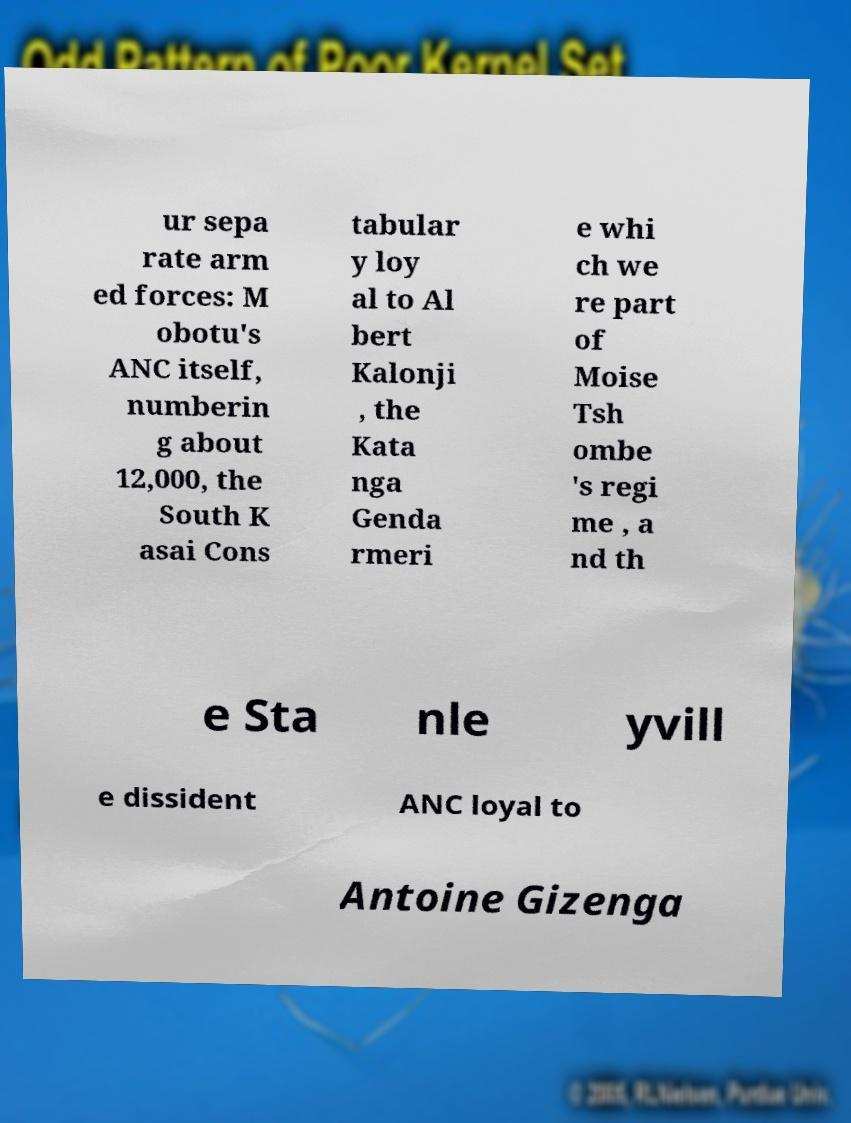Can you accurately transcribe the text from the provided image for me? ur sepa rate arm ed forces: M obotu's ANC itself, numberin g about 12,000, the South K asai Cons tabular y loy al to Al bert Kalonji , the Kata nga Genda rmeri e whi ch we re part of Moise Tsh ombe 's regi me , a nd th e Sta nle yvill e dissident ANC loyal to Antoine Gizenga 